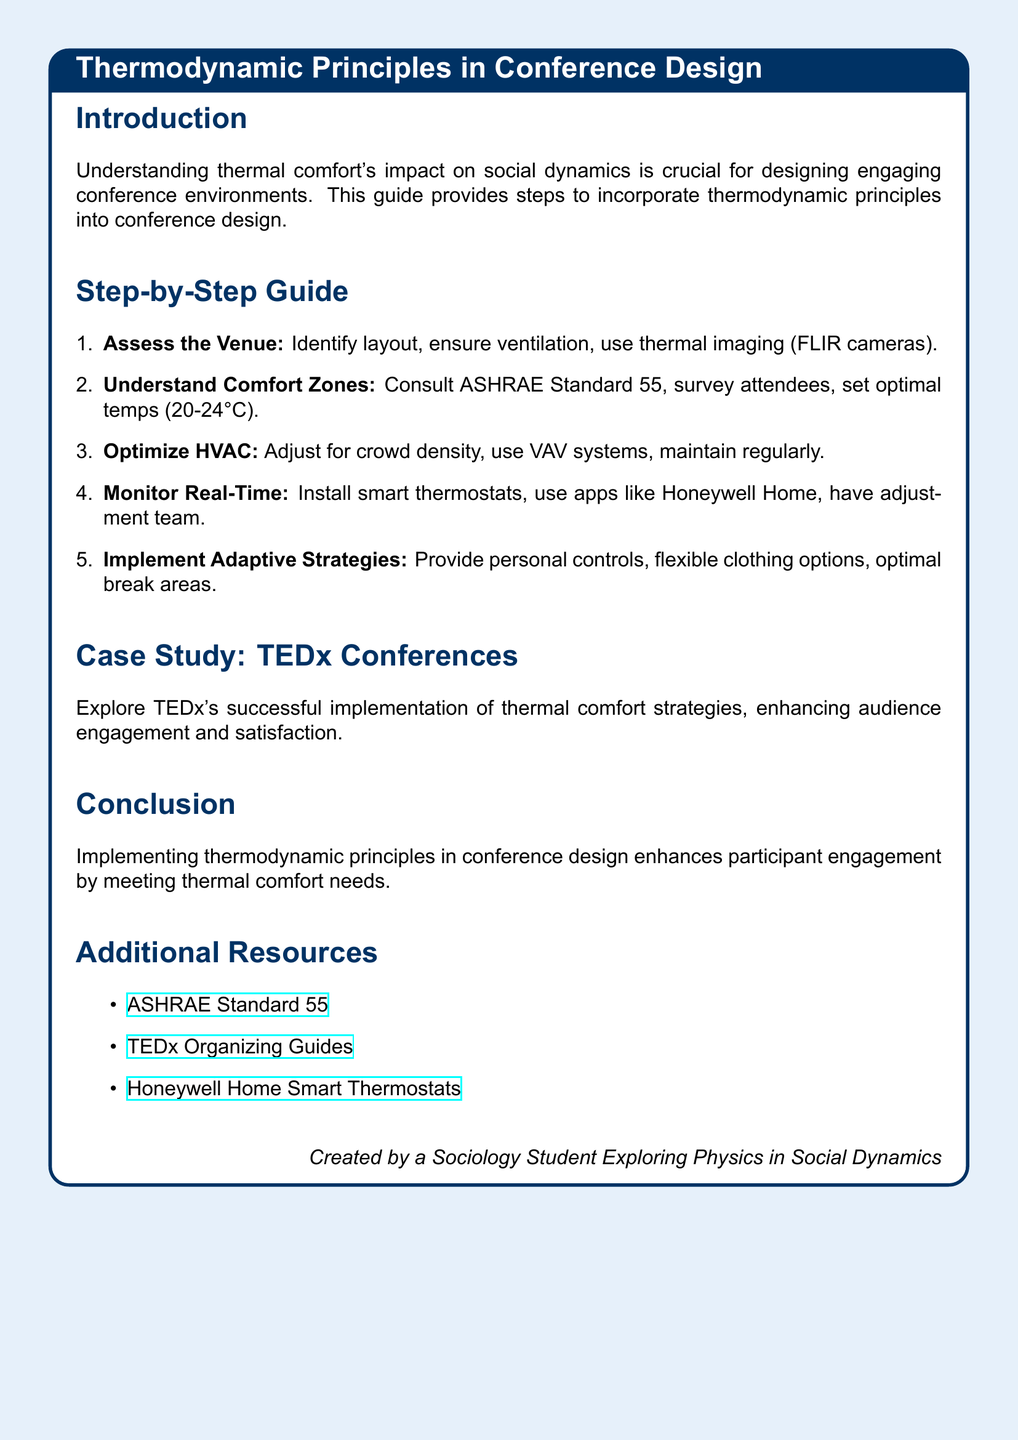What is the title of the document? The title is mentioned at the top of the recipe card, indicating the main focus of the document.
Answer: Thermodynamic Principles in Conference Design What standard is referenced for understanding comfort zones? The document refers to a specific standard that provides guidelines for thermal comfort.
Answer: ASHRAE Standard 55 What temperature range is suggested for optimal thermal comfort? The recommended temperature range for conference environments can be found in the section on comfort zones.
Answer: 20-24°C How many steps are outlined in the step-by-step guide? The total number of steps can be counted within the guide section of the document.
Answer: Five What case study is included in the document? The document includes an exemplary case study showcasing implementation of thermal comfort strategies.
Answer: TEDx Conferences What technology is recommended for monitoring real-time thermal comfort? The document specifies a type of device that aids in real-time adjustments based on thermal conditions.
Answer: Smart thermostats Which strategies are suggested for adaptive comfort? The document lists specific adaptive strategies that can be implemented to enhance comfort in conference settings.
Answer: Personal controls Who created the document? The footer mentions the creator's background, linking the document to the author's studies and interests.
Answer: A Sociology Student Exploring Physics in Social Dynamics 